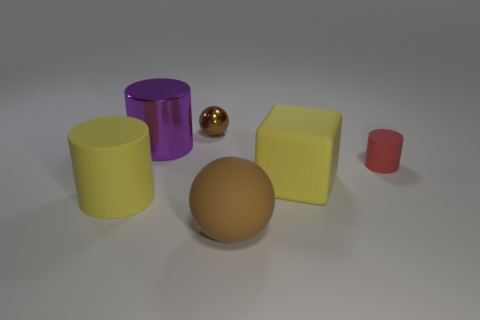Is the number of big things that are left of the big yellow cube greater than the number of large cubes that are in front of the yellow cylinder?
Make the answer very short. Yes. Are there any purple balls?
Your answer should be compact. No. There is a big thing that is the same color as the large matte cube; what material is it?
Provide a short and direct response. Rubber. How many objects are tiny brown things or tiny cyan objects?
Keep it short and to the point. 1. Is there a big rubber cylinder that has the same color as the large block?
Give a very brief answer. Yes. How many rubber things are right of the yellow rubber thing to the right of the big purple cylinder?
Ensure brevity in your answer.  1. Are there more small cylinders than small blue metal objects?
Provide a succinct answer. Yes. Is the material of the large brown thing the same as the tiny brown object?
Provide a short and direct response. No. Are there the same number of big balls behind the rubber ball and tiny shiny balls?
Ensure brevity in your answer.  No. How many other things have the same material as the big brown object?
Make the answer very short. 3. 